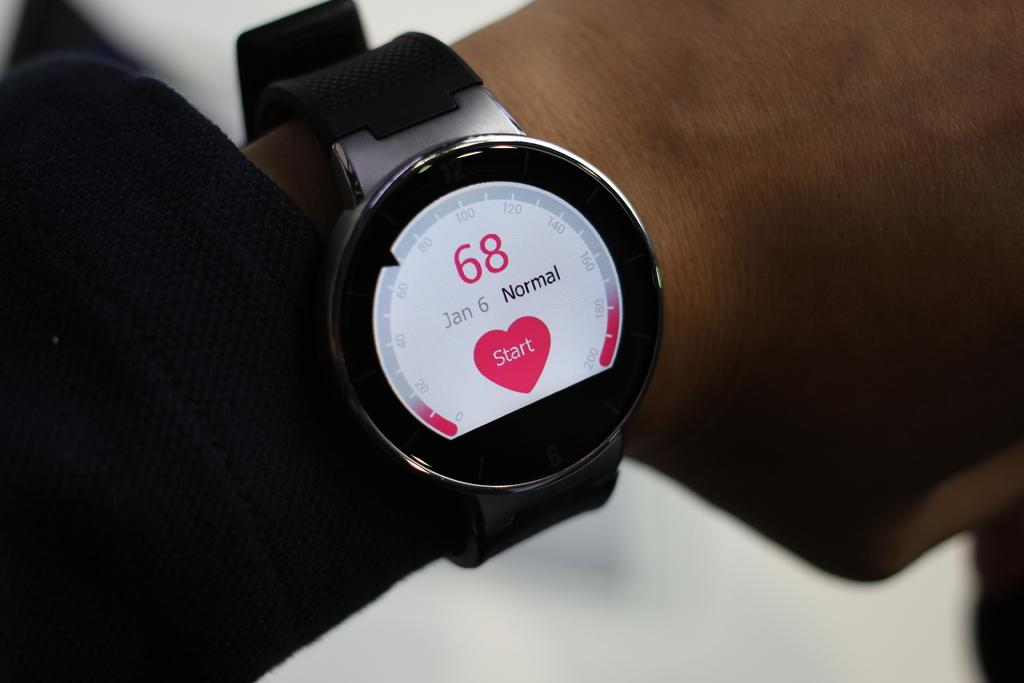What part of the human body is visible in the image? There is a human hand in the image. What color is the dress worn by the hand? The hand is wearing a black-colored dress. What other accessory is the hand wearing? The hand is also wearing a black-colored wristwatch. What is the color of the background in the image? The background of the image is white. What type of yam is being prepared by the hand in the image? There is no yam present in the image; it only shows a human hand wearing a black dress and wristwatch against a white background. 